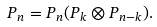<formula> <loc_0><loc_0><loc_500><loc_500>P _ { n } = P _ { n } ( P _ { k } \otimes P _ { n - k } ) .</formula> 